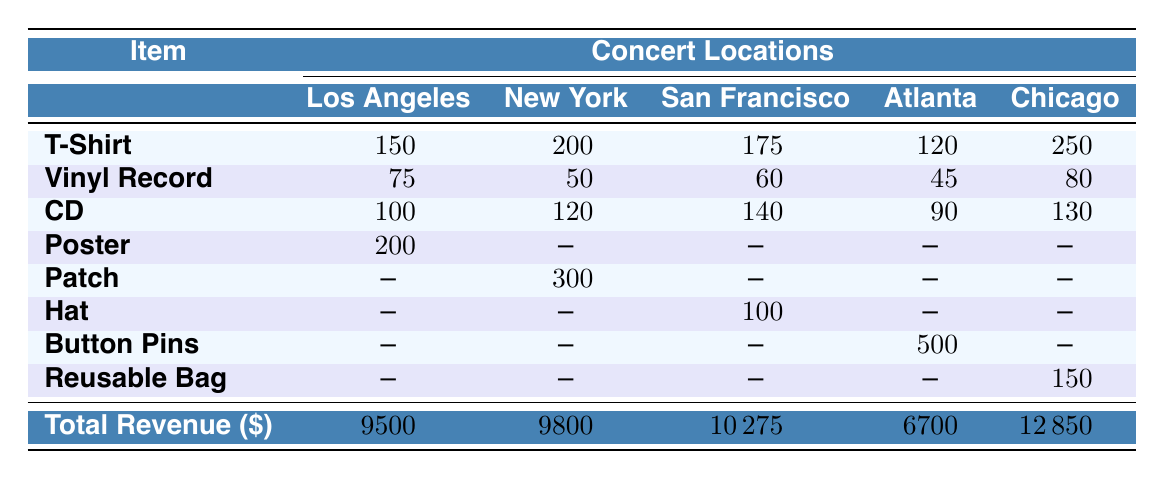What item had the highest sales quantity in Chicago? The T-Shirt had the highest sales quantity in Chicago with 250 units sold.
Answer: T-Shirt How many Poster items were sold at the New York concert? The Poster item was not sold at the New York concert, as indicated by the absence of a quantity value (represented by "--").
Answer: 0 What is the total revenue generated from merchandise sales in Atlanta? The total revenue for Atlanta is $6700 as shown in the last row of the table.
Answer: $6700 Which location sold the most quantity of Vinyl Records? The Troubadour in Los Angeles sold the most Vinyl Records with 75 units.
Answer: Los Angeles What is the average quantity sold for T-Shirts across all locations? The T-Shirt quantities sold are 150, 200, 175, 120, and 250. Summing them gives 895, and dividing by 5 gives an average of 179.
Answer: 179 Did the San Francisco concert sell any Patch items? No, the Patch item was not sold during the San Francisco concert as indicated by the absence of a quantity value (represented by "--").
Answer: No What was the total revenue from T-Shirts sold across all concerts? The quantities sold for T-Shirts are 150, 200, 175, 120, and 250. The revenue generated from T-Shirts can be calculated as (150*25 + 200*25 + 175*25 + 120*25 + 250*25) = 21925 dollars.
Answer: $21925 Which item had the lowest total sales in terms of quantity across all locations? The lowest total sales in terms of quantity is Vinyl Records with a sum of 75 + 50 + 60 + 45 + 80 = 310 units sold.
Answer: Vinyl Record What percentage of the total revenue in Los Angeles is made up by T-Shirt sales? The T-Shirt revenue in Los Angeles is $3750, with total revenue of $9500. The percentage is calculated as (3750 / 9500) * 100 = 39.47%.
Answer: 39.47% Which concert location had the lowest revenue from merchandise sales? Atlanta had the lowest revenue from merchandise sales, totaling $6700.
Answer: Atlanta What is the difference in quantity sold for CD items between New York and Atlanta? New York sold 120 CDs while Atlanta sold 90 CDs. The difference is 120 - 90 = 30 units.
Answer: 30 